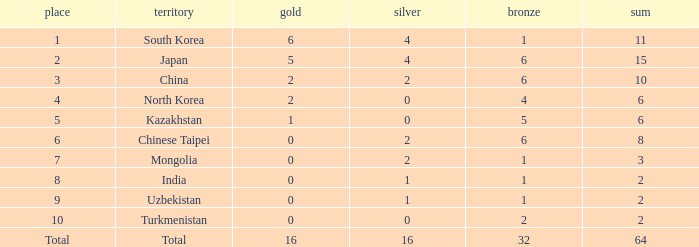How many Golds did Rank 10 get, with a Bronze larger than 2? 0.0. 